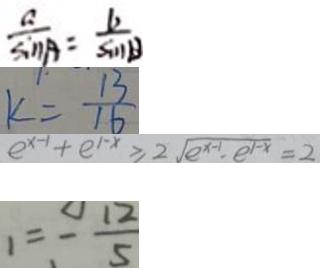Convert formula to latex. <formula><loc_0><loc_0><loc_500><loc_500>\frac { a } { \sin A } = \frac { b } { \sin B } 
 k = \frac { 1 3 } { 1 6 } 
 e ^ { x - 1 } + e ^ { 1 - x } \geq 2 \sqrt { e ^ { x - 1 } , e ^ { 1 - x } } = 2 
 1 = - \frac { 1 2 } { 5 }</formula> 